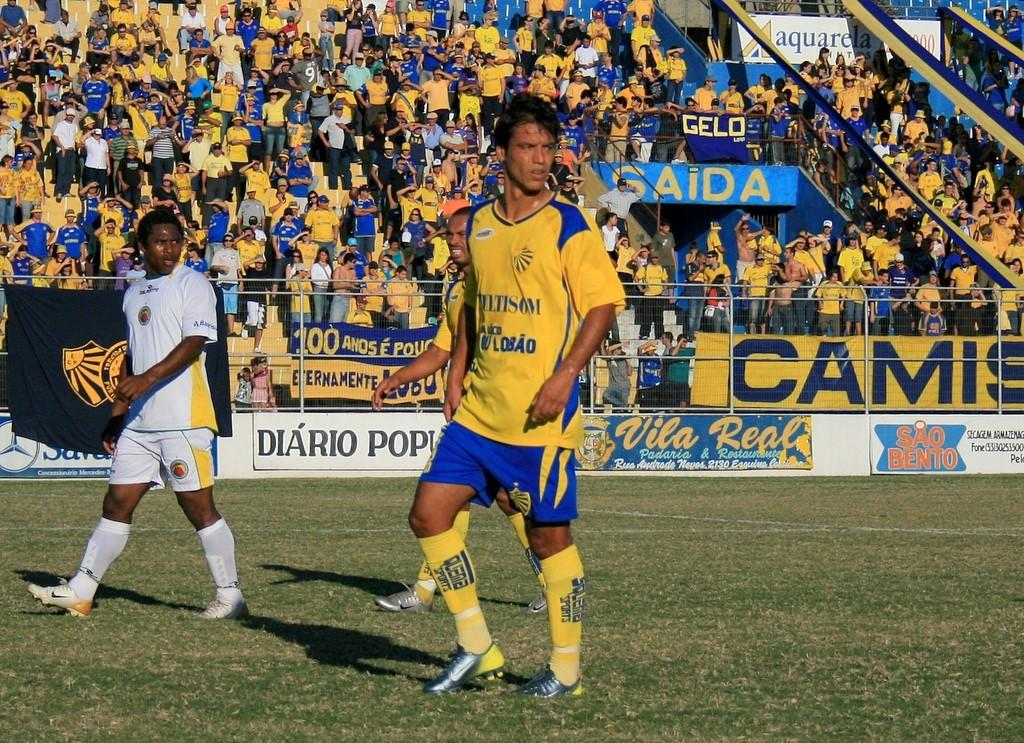<image>
Create a compact narrative representing the image presented. A soccer stadium entrance is framed by the word Saida. 